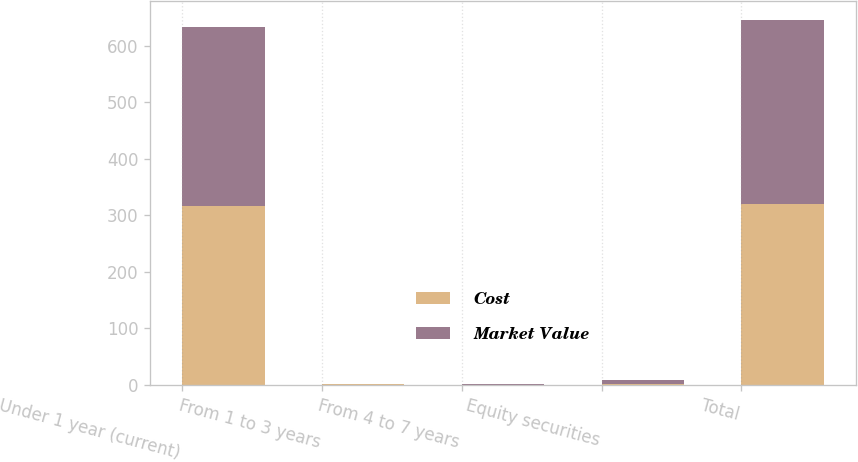<chart> <loc_0><loc_0><loc_500><loc_500><stacked_bar_chart><ecel><fcel>Under 1 year (current)<fcel>From 1 to 3 years<fcel>From 4 to 7 years<fcel>Equity securities<fcel>Total<nl><fcel>Cost<fcel>316.9<fcel>1.1<fcel>0.6<fcel>1.8<fcel>320.4<nl><fcel>Market Value<fcel>317.1<fcel>1.1<fcel>0.6<fcel>7.2<fcel>326<nl></chart> 